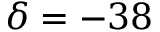Convert formula to latex. <formula><loc_0><loc_0><loc_500><loc_500>\delta = - 3 8</formula> 